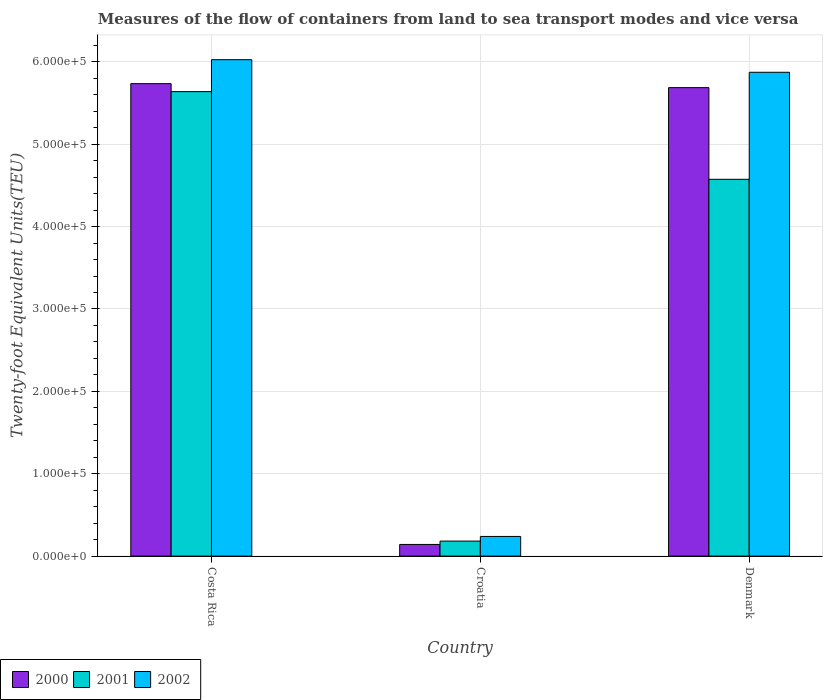What is the label of the 1st group of bars from the left?
Ensure brevity in your answer.  Costa Rica. In how many cases, is the number of bars for a given country not equal to the number of legend labels?
Provide a succinct answer. 0. What is the container port traffic in 2000 in Costa Rica?
Your answer should be very brief. 5.74e+05. Across all countries, what is the maximum container port traffic in 2002?
Your answer should be very brief. 6.03e+05. Across all countries, what is the minimum container port traffic in 2000?
Provide a short and direct response. 1.42e+04. In which country was the container port traffic in 2000 minimum?
Your answer should be compact. Croatia. What is the total container port traffic in 2000 in the graph?
Provide a short and direct response. 1.16e+06. What is the difference between the container port traffic in 2002 in Croatia and that in Denmark?
Keep it short and to the point. -5.63e+05. What is the difference between the container port traffic in 2000 in Denmark and the container port traffic in 2002 in Croatia?
Your response must be concise. 5.45e+05. What is the average container port traffic in 2002 per country?
Give a very brief answer. 4.05e+05. What is the difference between the container port traffic of/in 2001 and container port traffic of/in 2002 in Costa Rica?
Provide a short and direct response. -3.87e+04. What is the ratio of the container port traffic in 2000 in Costa Rica to that in Croatia?
Offer a terse response. 40.52. What is the difference between the highest and the second highest container port traffic in 2001?
Offer a very short reply. 1.06e+05. What is the difference between the highest and the lowest container port traffic in 2000?
Offer a terse response. 5.59e+05. What does the 2nd bar from the left in Croatia represents?
Your answer should be very brief. 2001. Are all the bars in the graph horizontal?
Provide a short and direct response. No. How many countries are there in the graph?
Offer a terse response. 3. What is the difference between two consecutive major ticks on the Y-axis?
Ensure brevity in your answer.  1.00e+05. Are the values on the major ticks of Y-axis written in scientific E-notation?
Your response must be concise. Yes. Does the graph contain any zero values?
Provide a succinct answer. No. Does the graph contain grids?
Your answer should be compact. Yes. Where does the legend appear in the graph?
Provide a succinct answer. Bottom left. How many legend labels are there?
Provide a short and direct response. 3. What is the title of the graph?
Provide a short and direct response. Measures of the flow of containers from land to sea transport modes and vice versa. Does "2008" appear as one of the legend labels in the graph?
Offer a terse response. No. What is the label or title of the Y-axis?
Offer a very short reply. Twenty-foot Equivalent Units(TEU). What is the Twenty-foot Equivalent Units(TEU) of 2000 in Costa Rica?
Give a very brief answer. 5.74e+05. What is the Twenty-foot Equivalent Units(TEU) of 2001 in Costa Rica?
Provide a succinct answer. 5.64e+05. What is the Twenty-foot Equivalent Units(TEU) of 2002 in Costa Rica?
Ensure brevity in your answer.  6.03e+05. What is the Twenty-foot Equivalent Units(TEU) in 2000 in Croatia?
Offer a very short reply. 1.42e+04. What is the Twenty-foot Equivalent Units(TEU) in 2001 in Croatia?
Your answer should be very brief. 1.82e+04. What is the Twenty-foot Equivalent Units(TEU) in 2002 in Croatia?
Provide a succinct answer. 2.39e+04. What is the Twenty-foot Equivalent Units(TEU) in 2000 in Denmark?
Your answer should be very brief. 5.69e+05. What is the Twenty-foot Equivalent Units(TEU) of 2001 in Denmark?
Keep it short and to the point. 4.57e+05. What is the Twenty-foot Equivalent Units(TEU) in 2002 in Denmark?
Make the answer very short. 5.87e+05. Across all countries, what is the maximum Twenty-foot Equivalent Units(TEU) of 2000?
Offer a terse response. 5.74e+05. Across all countries, what is the maximum Twenty-foot Equivalent Units(TEU) of 2001?
Your answer should be very brief. 5.64e+05. Across all countries, what is the maximum Twenty-foot Equivalent Units(TEU) in 2002?
Your answer should be very brief. 6.03e+05. Across all countries, what is the minimum Twenty-foot Equivalent Units(TEU) of 2000?
Provide a short and direct response. 1.42e+04. Across all countries, what is the minimum Twenty-foot Equivalent Units(TEU) of 2001?
Ensure brevity in your answer.  1.82e+04. Across all countries, what is the minimum Twenty-foot Equivalent Units(TEU) of 2002?
Provide a succinct answer. 2.39e+04. What is the total Twenty-foot Equivalent Units(TEU) of 2000 in the graph?
Give a very brief answer. 1.16e+06. What is the total Twenty-foot Equivalent Units(TEU) in 2001 in the graph?
Give a very brief answer. 1.04e+06. What is the total Twenty-foot Equivalent Units(TEU) in 2002 in the graph?
Your answer should be compact. 1.21e+06. What is the difference between the Twenty-foot Equivalent Units(TEU) in 2000 in Costa Rica and that in Croatia?
Provide a succinct answer. 5.59e+05. What is the difference between the Twenty-foot Equivalent Units(TEU) of 2001 in Costa Rica and that in Croatia?
Give a very brief answer. 5.46e+05. What is the difference between the Twenty-foot Equivalent Units(TEU) of 2002 in Costa Rica and that in Croatia?
Your answer should be compact. 5.79e+05. What is the difference between the Twenty-foot Equivalent Units(TEU) of 2000 in Costa Rica and that in Denmark?
Give a very brief answer. 4842. What is the difference between the Twenty-foot Equivalent Units(TEU) in 2001 in Costa Rica and that in Denmark?
Keep it short and to the point. 1.06e+05. What is the difference between the Twenty-foot Equivalent Units(TEU) of 2002 in Costa Rica and that in Denmark?
Provide a succinct answer. 1.53e+04. What is the difference between the Twenty-foot Equivalent Units(TEU) of 2000 in Croatia and that in Denmark?
Offer a terse response. -5.55e+05. What is the difference between the Twenty-foot Equivalent Units(TEU) of 2001 in Croatia and that in Denmark?
Your response must be concise. -4.39e+05. What is the difference between the Twenty-foot Equivalent Units(TEU) in 2002 in Croatia and that in Denmark?
Provide a short and direct response. -5.63e+05. What is the difference between the Twenty-foot Equivalent Units(TEU) in 2000 in Costa Rica and the Twenty-foot Equivalent Units(TEU) in 2001 in Croatia?
Give a very brief answer. 5.55e+05. What is the difference between the Twenty-foot Equivalent Units(TEU) of 2000 in Costa Rica and the Twenty-foot Equivalent Units(TEU) of 2002 in Croatia?
Your answer should be compact. 5.50e+05. What is the difference between the Twenty-foot Equivalent Units(TEU) of 2001 in Costa Rica and the Twenty-foot Equivalent Units(TEU) of 2002 in Croatia?
Ensure brevity in your answer.  5.40e+05. What is the difference between the Twenty-foot Equivalent Units(TEU) in 2000 in Costa Rica and the Twenty-foot Equivalent Units(TEU) in 2001 in Denmark?
Offer a terse response. 1.16e+05. What is the difference between the Twenty-foot Equivalent Units(TEU) in 2000 in Costa Rica and the Twenty-foot Equivalent Units(TEU) in 2002 in Denmark?
Your answer should be very brief. -1.38e+04. What is the difference between the Twenty-foot Equivalent Units(TEU) of 2001 in Costa Rica and the Twenty-foot Equivalent Units(TEU) of 2002 in Denmark?
Ensure brevity in your answer.  -2.35e+04. What is the difference between the Twenty-foot Equivalent Units(TEU) of 2000 in Croatia and the Twenty-foot Equivalent Units(TEU) of 2001 in Denmark?
Make the answer very short. -4.43e+05. What is the difference between the Twenty-foot Equivalent Units(TEU) of 2000 in Croatia and the Twenty-foot Equivalent Units(TEU) of 2002 in Denmark?
Your response must be concise. -5.73e+05. What is the difference between the Twenty-foot Equivalent Units(TEU) of 2001 in Croatia and the Twenty-foot Equivalent Units(TEU) of 2002 in Denmark?
Keep it short and to the point. -5.69e+05. What is the average Twenty-foot Equivalent Units(TEU) of 2000 per country?
Make the answer very short. 3.85e+05. What is the average Twenty-foot Equivalent Units(TEU) in 2001 per country?
Give a very brief answer. 3.46e+05. What is the average Twenty-foot Equivalent Units(TEU) in 2002 per country?
Your answer should be very brief. 4.05e+05. What is the difference between the Twenty-foot Equivalent Units(TEU) of 2000 and Twenty-foot Equivalent Units(TEU) of 2001 in Costa Rica?
Make the answer very short. 9677. What is the difference between the Twenty-foot Equivalent Units(TEU) in 2000 and Twenty-foot Equivalent Units(TEU) in 2002 in Costa Rica?
Give a very brief answer. -2.91e+04. What is the difference between the Twenty-foot Equivalent Units(TEU) of 2001 and Twenty-foot Equivalent Units(TEU) of 2002 in Costa Rica?
Your answer should be compact. -3.87e+04. What is the difference between the Twenty-foot Equivalent Units(TEU) of 2000 and Twenty-foot Equivalent Units(TEU) of 2001 in Croatia?
Ensure brevity in your answer.  -4065. What is the difference between the Twenty-foot Equivalent Units(TEU) of 2000 and Twenty-foot Equivalent Units(TEU) of 2002 in Croatia?
Ensure brevity in your answer.  -9700. What is the difference between the Twenty-foot Equivalent Units(TEU) in 2001 and Twenty-foot Equivalent Units(TEU) in 2002 in Croatia?
Keep it short and to the point. -5635. What is the difference between the Twenty-foot Equivalent Units(TEU) of 2000 and Twenty-foot Equivalent Units(TEU) of 2001 in Denmark?
Your response must be concise. 1.11e+05. What is the difference between the Twenty-foot Equivalent Units(TEU) of 2000 and Twenty-foot Equivalent Units(TEU) of 2002 in Denmark?
Provide a short and direct response. -1.86e+04. What is the difference between the Twenty-foot Equivalent Units(TEU) in 2001 and Twenty-foot Equivalent Units(TEU) in 2002 in Denmark?
Your answer should be compact. -1.30e+05. What is the ratio of the Twenty-foot Equivalent Units(TEU) in 2000 in Costa Rica to that in Croatia?
Give a very brief answer. 40.52. What is the ratio of the Twenty-foot Equivalent Units(TEU) of 2001 in Costa Rica to that in Croatia?
Provide a succinct answer. 30.95. What is the ratio of the Twenty-foot Equivalent Units(TEU) in 2002 in Costa Rica to that in Croatia?
Ensure brevity in your answer.  25.26. What is the ratio of the Twenty-foot Equivalent Units(TEU) in 2000 in Costa Rica to that in Denmark?
Your answer should be very brief. 1.01. What is the ratio of the Twenty-foot Equivalent Units(TEU) of 2001 in Costa Rica to that in Denmark?
Offer a terse response. 1.23. What is the ratio of the Twenty-foot Equivalent Units(TEU) of 2000 in Croatia to that in Denmark?
Your answer should be compact. 0.02. What is the ratio of the Twenty-foot Equivalent Units(TEU) of 2001 in Croatia to that in Denmark?
Make the answer very short. 0.04. What is the ratio of the Twenty-foot Equivalent Units(TEU) of 2002 in Croatia to that in Denmark?
Ensure brevity in your answer.  0.04. What is the difference between the highest and the second highest Twenty-foot Equivalent Units(TEU) of 2000?
Offer a very short reply. 4842. What is the difference between the highest and the second highest Twenty-foot Equivalent Units(TEU) of 2001?
Offer a terse response. 1.06e+05. What is the difference between the highest and the second highest Twenty-foot Equivalent Units(TEU) of 2002?
Give a very brief answer. 1.53e+04. What is the difference between the highest and the lowest Twenty-foot Equivalent Units(TEU) of 2000?
Your answer should be very brief. 5.59e+05. What is the difference between the highest and the lowest Twenty-foot Equivalent Units(TEU) of 2001?
Keep it short and to the point. 5.46e+05. What is the difference between the highest and the lowest Twenty-foot Equivalent Units(TEU) of 2002?
Ensure brevity in your answer.  5.79e+05. 